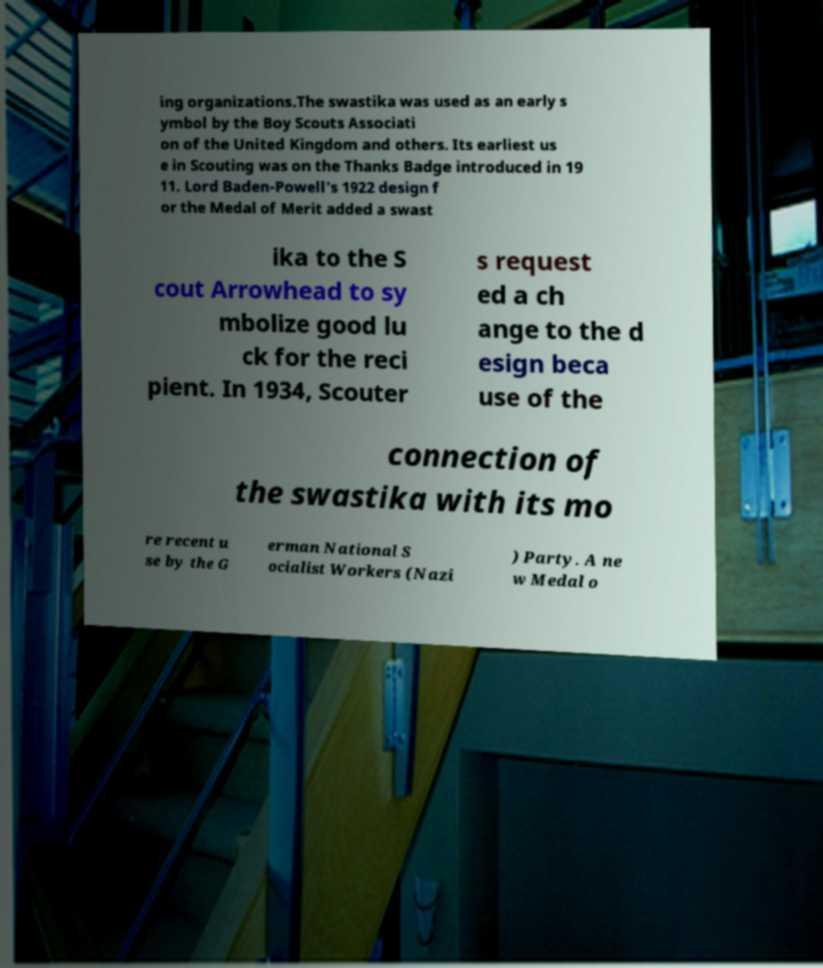Please read and relay the text visible in this image. What does it say? ing organizations.The swastika was used as an early s ymbol by the Boy Scouts Associati on of the United Kingdom and others. Its earliest us e in Scouting was on the Thanks Badge introduced in 19 11. Lord Baden-Powell's 1922 design f or the Medal of Merit added a swast ika to the S cout Arrowhead to sy mbolize good lu ck for the reci pient. In 1934, Scouter s request ed a ch ange to the d esign beca use of the connection of the swastika with its mo re recent u se by the G erman National S ocialist Workers (Nazi ) Party. A ne w Medal o 